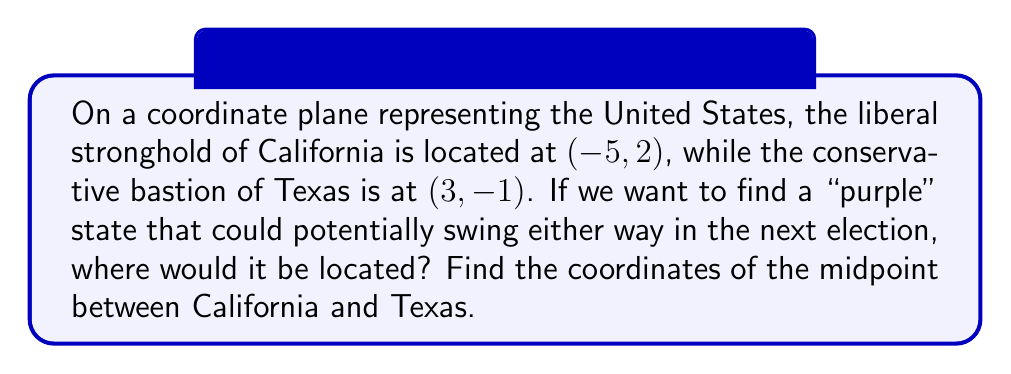Provide a solution to this math problem. To find the midpoint between two points on a coordinate plane, we use the midpoint formula:

$$ \text{Midpoint} = \left(\frac{x_1 + x_2}{2}, \frac{y_1 + y_2}{2}\right) $$

Where $(x_1, y_1)$ represents the coordinates of the first point (California) and $(x_2, y_2)$ represents the coordinates of the second point (Texas).

Let's plug in our values:

California: $(-5, 2)$
Texas: $(3, -1)$

$$ x_{\text{midpoint}} = \frac{-5 + 3}{2} = \frac{-2}{2} = -1 $$

$$ y_{\text{midpoint}} = \frac{2 + (-1)}{2} = \frac{1}{2} = 0.5 $$

Therefore, the midpoint coordinates are $(-1, 0.5)$.

This point represents a hypothetical "purple" state that balances the liberal influence of California with the conservative influence of Texas, potentially swinging either way in future elections.
Answer: $(-1, 0.5)$ 